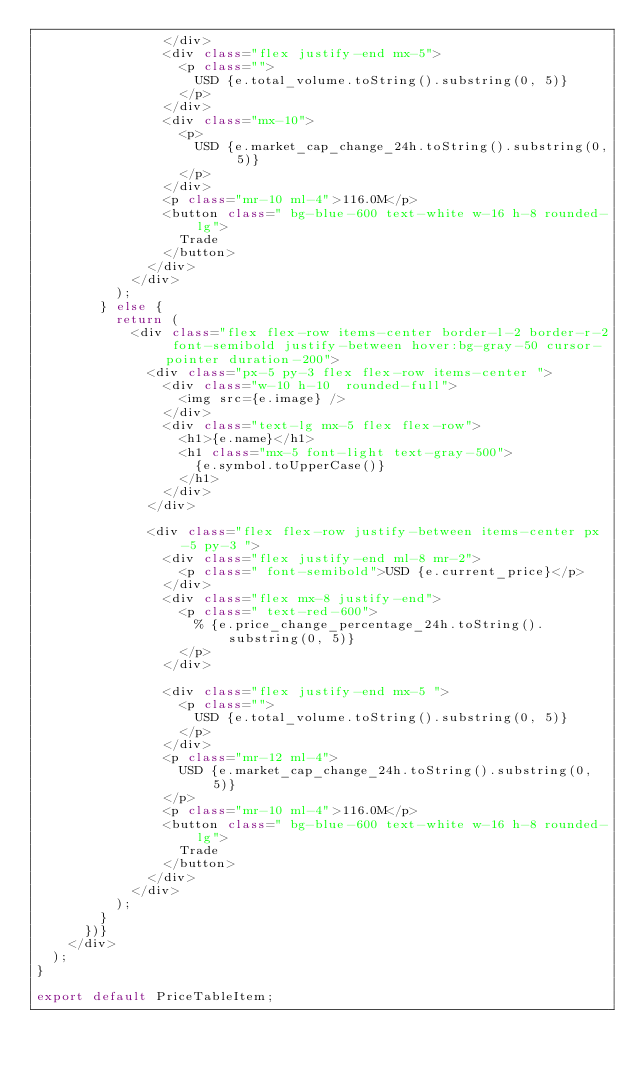<code> <loc_0><loc_0><loc_500><loc_500><_JavaScript_>                </div>
                <div class="flex justify-end mx-5">
                  <p class="">
                    USD {e.total_volume.toString().substring(0, 5)}
                  </p>
                </div>
                <div class="mx-10">
                  <p>
                    USD {e.market_cap_change_24h.toString().substring(0, 5)}
                  </p>
                </div>
                <p class="mr-10 ml-4">116.0M</p>
                <button class=" bg-blue-600 text-white w-16 h-8 rounded-lg">
                  Trade
                </button>
              </div>
            </div>
          );
        } else {
          return (
            <div class="flex flex-row items-center border-l-2 border-r-2 font-semibold justify-between hover:bg-gray-50 cursor-pointer duration-200">
              <div class="px-5 py-3 flex flex-row items-center ">
                <div class="w-10 h-10  rounded-full">
                  <img src={e.image} />
                </div>
                <div class="text-lg mx-5 flex flex-row">
                  <h1>{e.name}</h1>
                  <h1 class="mx-5 font-light text-gray-500">
                    {e.symbol.toUpperCase()}
                  </h1>
                </div>
              </div>

              <div class="flex flex-row justify-between items-center px-5 py-3 ">
                <div class="flex justify-end ml-8 mr-2">
                  <p class=" font-semibold">USD {e.current_price}</p>
                </div>
                <div class="flex mx-8 justify-end">
                  <p class=" text-red-600">
                    % {e.price_change_percentage_24h.toString().substring(0, 5)}
                  </p>
                </div>

                <div class="flex justify-end mx-5 ">
                  <p class="">
                    USD {e.total_volume.toString().substring(0, 5)}
                  </p>
                </div>
                <p class="mr-12 ml-4">
                  USD {e.market_cap_change_24h.toString().substring(0, 5)}
                </p>
                <p class="mr-10 ml-4">116.0M</p>
                <button class=" bg-blue-600 text-white w-16 h-8 rounded-lg">
                  Trade
                </button>
              </div>
            </div>
          );
        }
      })}
    </div>
  );
}

export default PriceTableItem;
</code> 